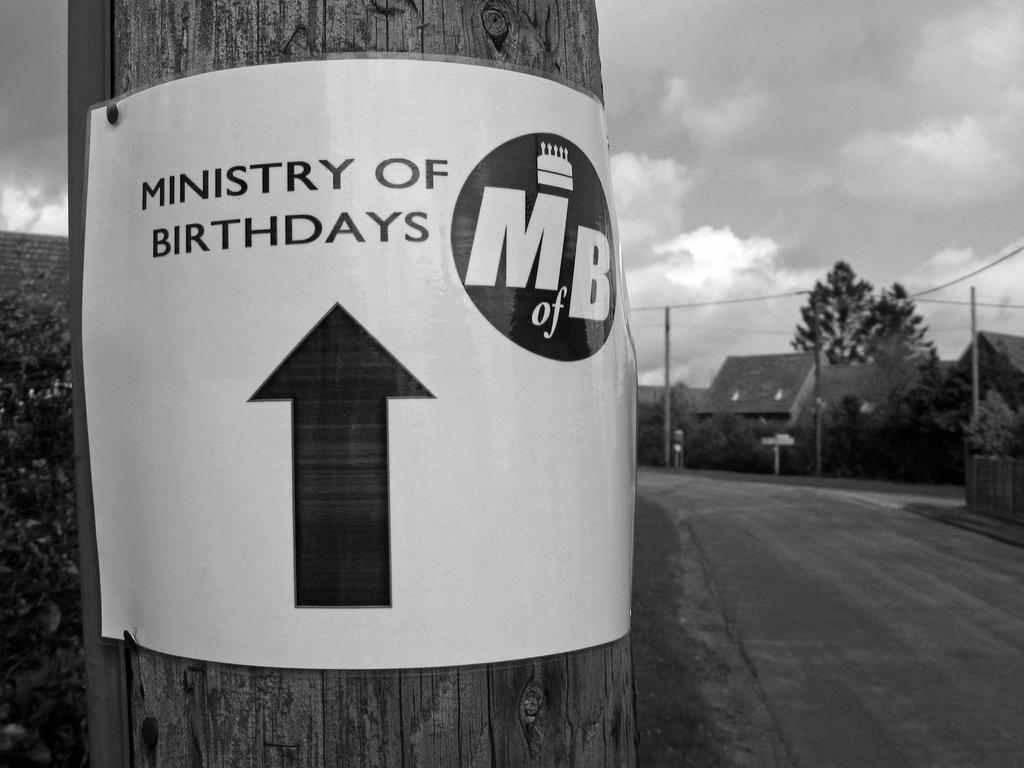<image>
Summarize the visual content of the image. A sign pointing towards the ministry of birthdays is posted to a telephone pole. 